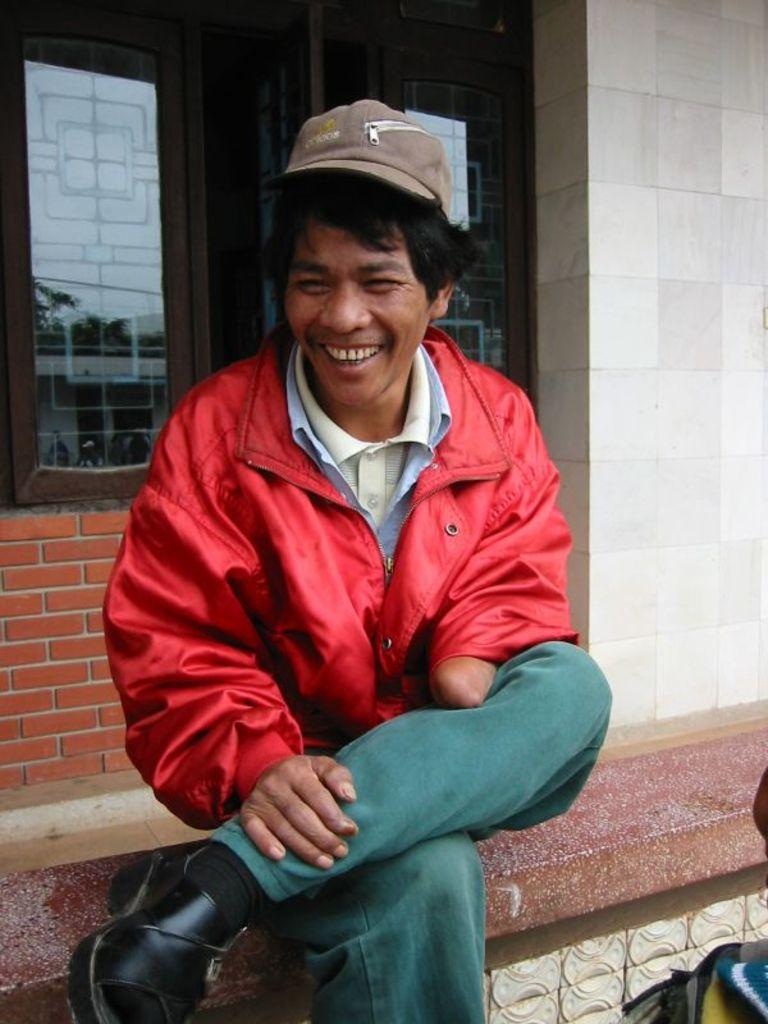What is the person in the image wearing on their head? The person is wearing a cap. What color is the jacket the person is wearing? The person is wearing a red jacket. What is the person's facial expression in the image? The person is smiling. Where is the person sitting in the image? The person is sitting on a wall. What can be seen in the background of the image? There is a window in the background. What is the wall behind the window made of? The wall behind the window is made of bricks. What type of pets can be seen playing with the person in the image? There are no pets visible in the image. How many dinosaurs are present in the image? There are no dinosaurs present in the image. 